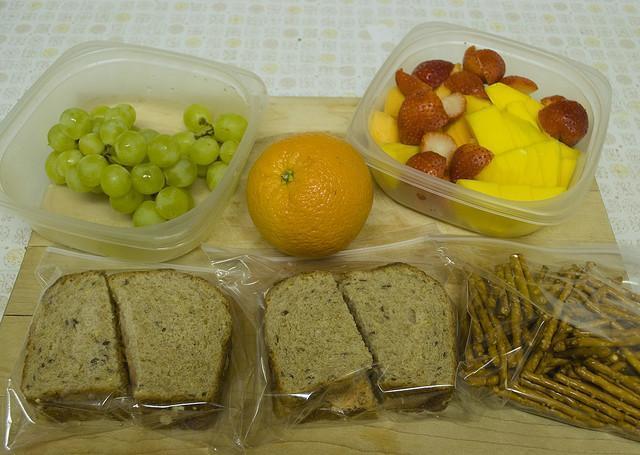How many containers are in the photo?
Give a very brief answer. 2. How many yellow donuts are on the table?
Give a very brief answer. 0. How many different kinds of yellow fruit are in the bowl?
Give a very brief answer. 1. How many bowls are there?
Give a very brief answer. 2. How many sandwiches are visible?
Give a very brief answer. 4. 